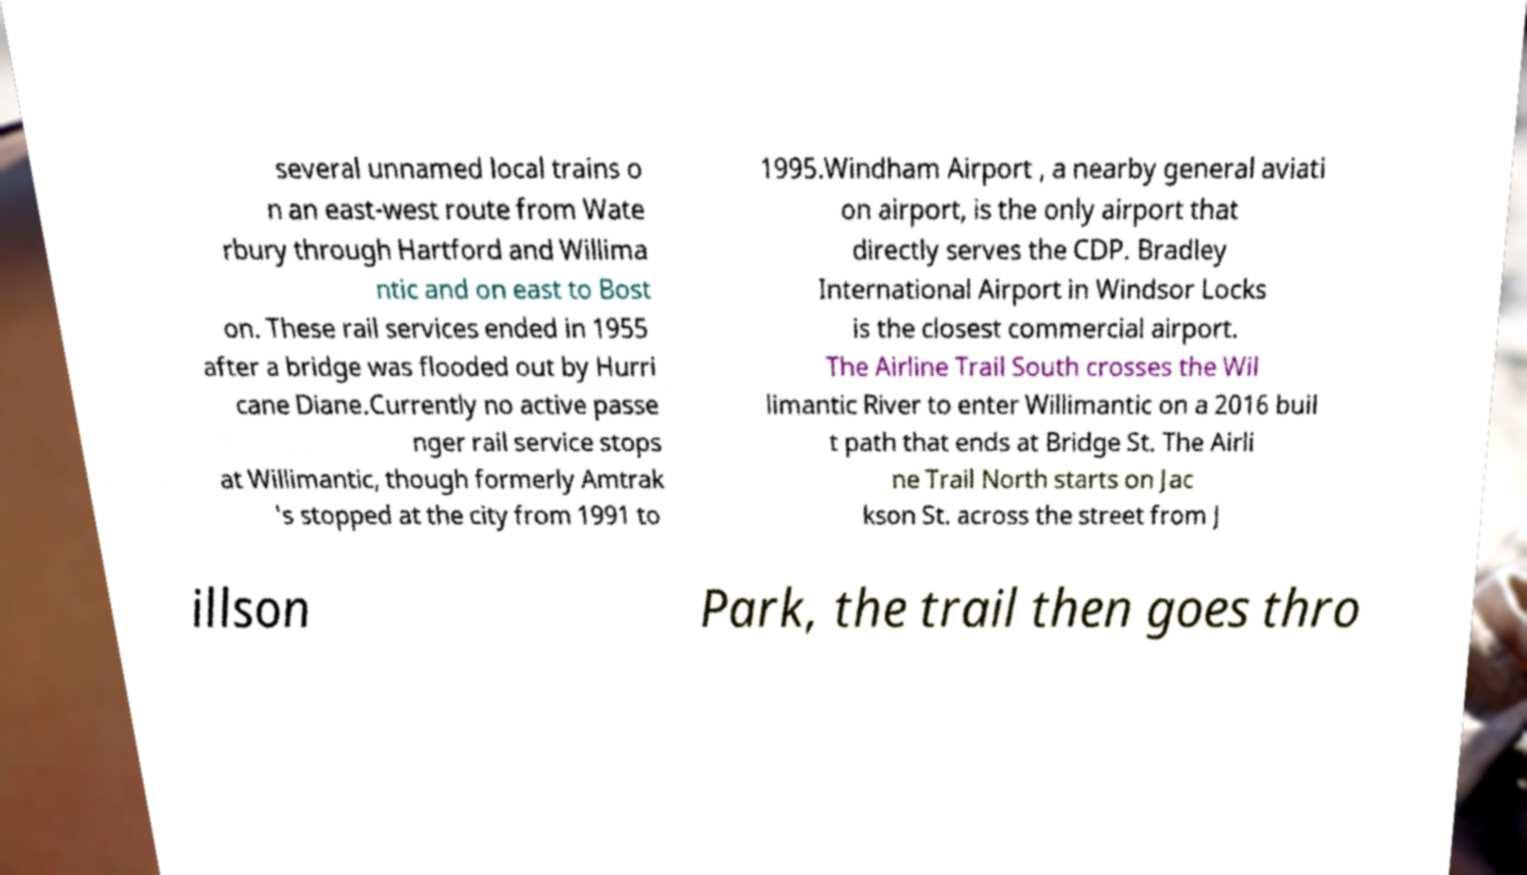Can you read and provide the text displayed in the image?This photo seems to have some interesting text. Can you extract and type it out for me? several unnamed local trains o n an east-west route from Wate rbury through Hartford and Willima ntic and on east to Bost on. These rail services ended in 1955 after a bridge was flooded out by Hurri cane Diane.Currently no active passe nger rail service stops at Willimantic, though formerly Amtrak 's stopped at the city from 1991 to 1995.Windham Airport , a nearby general aviati on airport, is the only airport that directly serves the CDP. Bradley International Airport in Windsor Locks is the closest commercial airport. The Airline Trail South crosses the Wil limantic River to enter Willimantic on a 2016 buil t path that ends at Bridge St. The Airli ne Trail North starts on Jac kson St. across the street from J illson Park, the trail then goes thro 